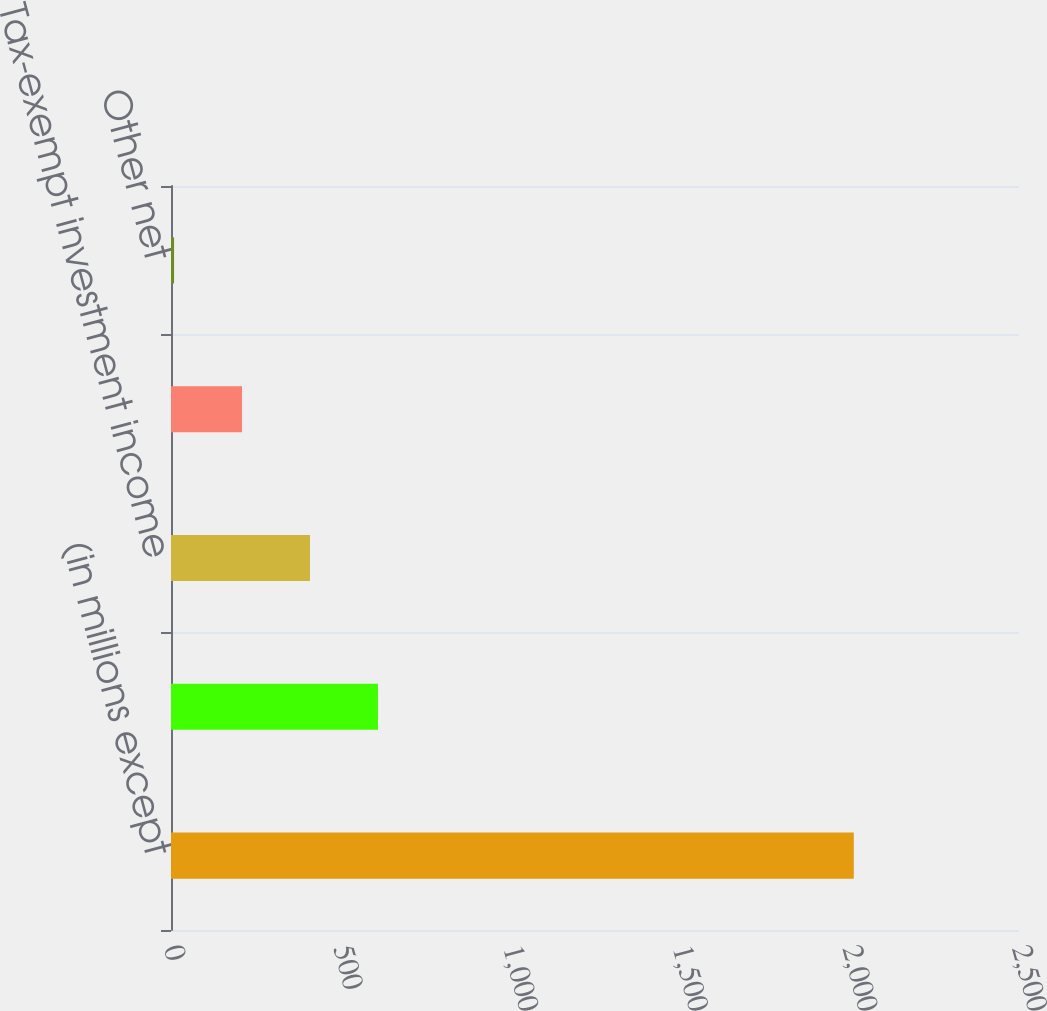Convert chart. <chart><loc_0><loc_0><loc_500><loc_500><bar_chart><fcel>(in millions except<fcel>State income taxes net of<fcel>Tax-exempt investment income<fcel>Non-deductible compensation<fcel>Other net<nl><fcel>2013<fcel>610.2<fcel>409.8<fcel>209.4<fcel>9<nl></chart> 